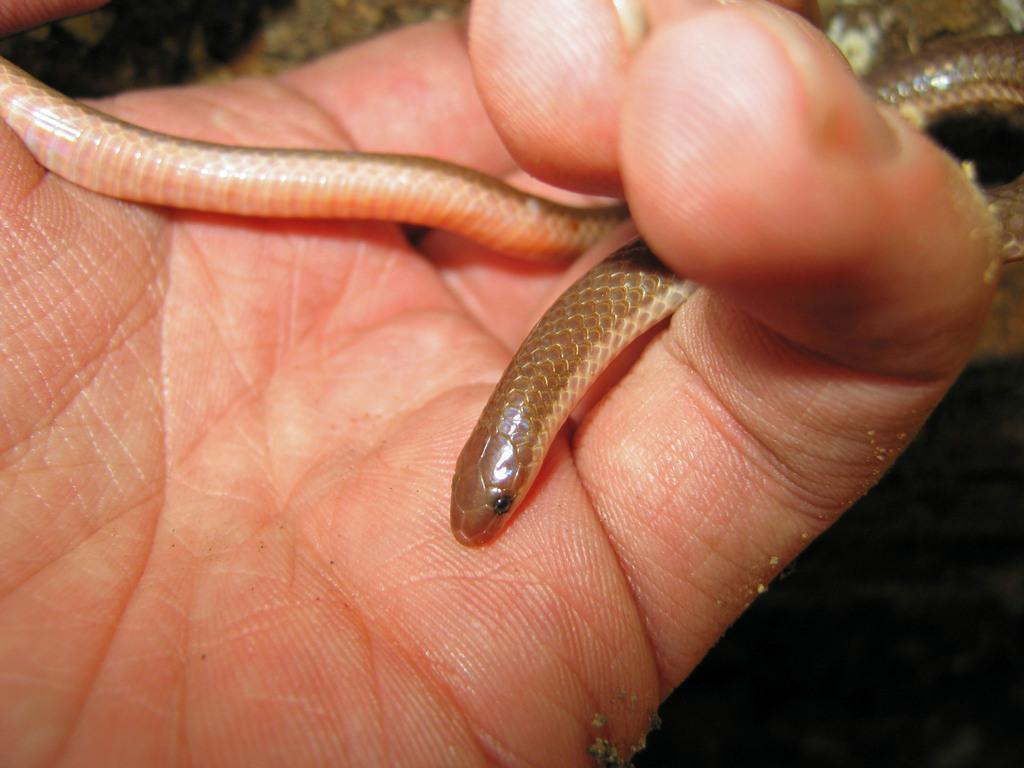What part of a person can be seen in the image? There is a hand of a person in the image. What animal is present in the image? A snake is present in the image. What is the color of the background in the image? The background of the image is dark. How many volleyballs can be seen in the image? There are no volleyballs present in the image. What type of sorting is being done in the image? There is no sorting activity depicted in the image. 